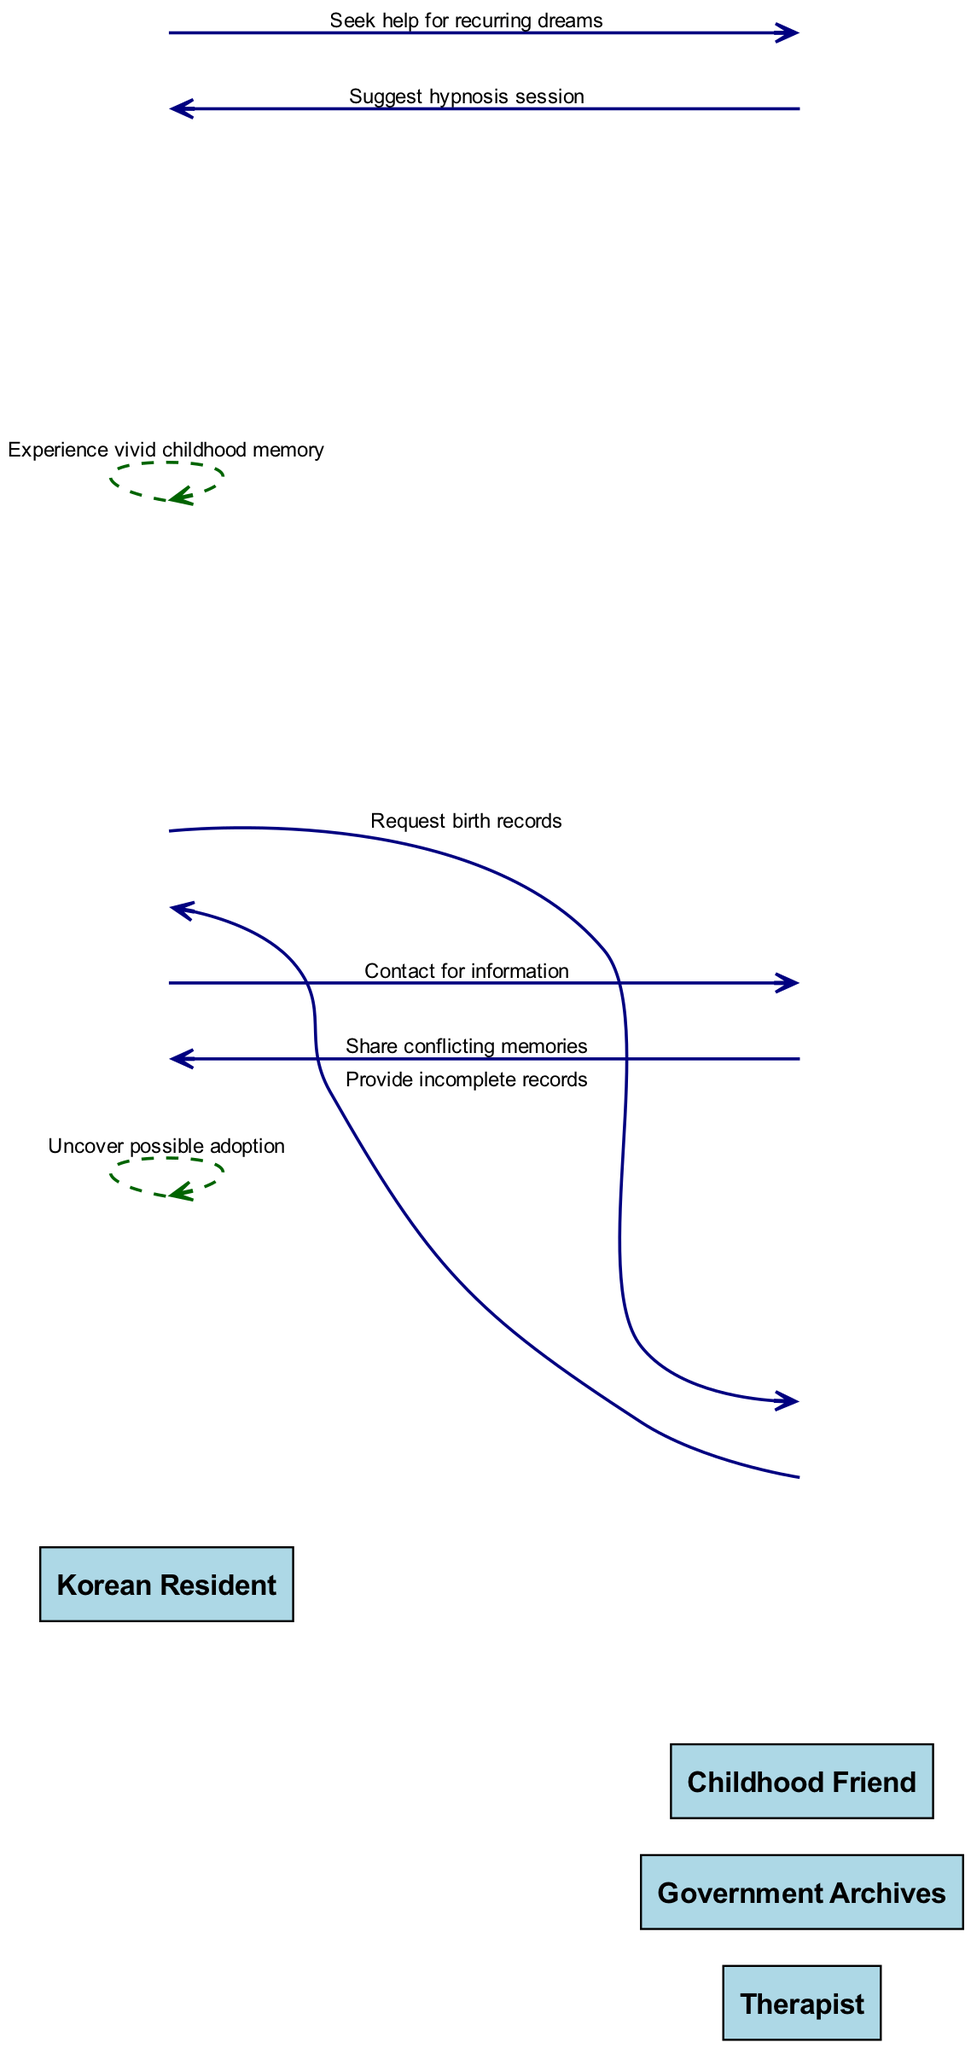What action does the Korean Resident take after experiencing vivid childhood memory? According to the sequence, the Korean Resident then requests birth records from the Government Archives, indicating a step towards uncovering their past.
Answer: Request birth records How many actors are involved in the sequence diagram? The diagram lists four actors: Korean Resident, Therapist, Government Archives, and Childhood Friend. So, the total number of actors is four.
Answer: Four What is the final action of the Korean Resident in the sequence? The last action recorded in the sequence for the Korean Resident is "Uncover possible adoption," reflecting the culmination of their efforts to unravel their past.
Answer: Uncover possible adoption Who provides the records to the Korean Resident? The Government Archives provide the incomplete records, as per the interaction described in the sequence.
Answer: Government Archives What is the relationship between the Korean Resident and the Childhood Friend in this sequence? The Korean Resident reaches out to the Childhood Friend for information, suggesting a line of inquiry connecting them to past memories.
Answer: Contact for information What kind of memories does the Childhood Friend share? The Childhood Friend shares conflicting memories, indicating discrepancies in their recollections that add complexity to the Korean Resident's search for truth.
Answer: Share conflicting memories Which action suggests a trigger for the Korean Resident's inquiry? The action "Seek help for recurring dreams" indicates the starting point for the Korean Resident's inquiry, showing that these dreams provoked their quest for answers.
Answer: Seek help for recurring dreams In what context does the Therapist assist the Korean Resident? The Therapist suggests a hypnosis session, indicating their role in guiding the Korean Resident towards exploring hidden aspects of their memories.
Answer: Suggest hypnosis session What is the nature of the records received from the Government Archives? The records received from the Government Archives are described as incomplete, which implies that they do not provide full clarity on the Korean Resident's background.
Answer: Provide incomplete records 